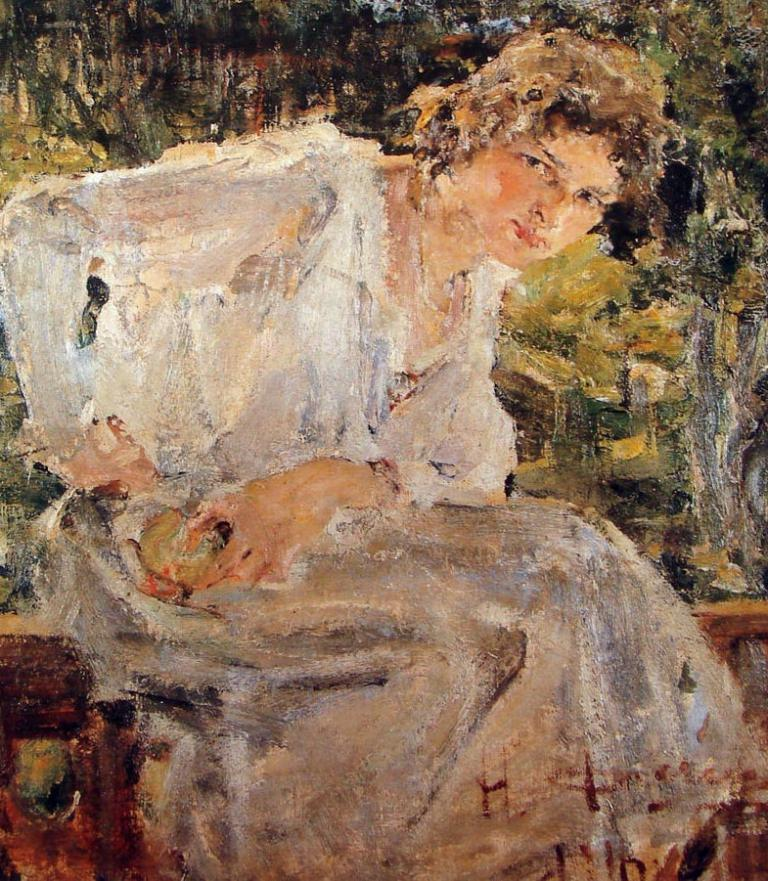What type of artwork is depicted in the image? The image is a painting. Can you describe the subject of the painting? There is a person in the painting. What is the person in the painting doing? The person is sitting on a chair. What is the person wearing in the painting? The person is wearing a white dress. What scientific experiment is being conducted in the painting? There is no scientific experiment present in the painting; it features a person sitting on a chair while wearing a white dress. Can you describe the kiss between the two people in the painting? There are no two people or any kiss depicted in the painting; it only shows a person sitting on a chair while wearing a white dress. 